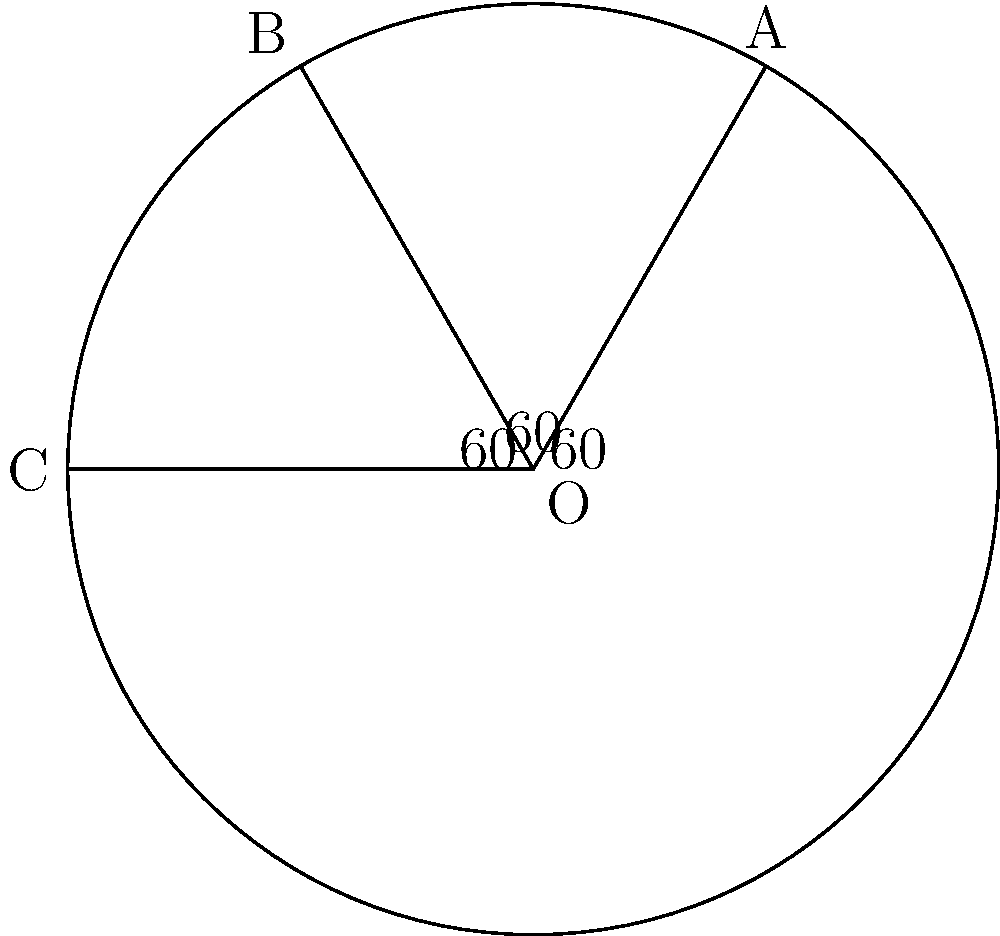In your 19th-century literature reading room, you've arranged three open books on a circular table, representing works by William Gilmore Simms. The books form three central angles of equal measure. If the angle between the first and third book is 120°, what is the measure of the angle formed by each open book? Let's approach this step-by-step:

1) First, let's recall that the sum of angles in a circle is 360°.

2) We're told that the books form three central angles of equal measure. Let's call the measure of each angle $x°$.

3) We're also told that the angle between the first and third book is 120°. This means that the sum of two of our equal angles is 120°.

4) We can express this as an equation:
   $2x = 120°$

5) Solving for $x$:
   $x = 120° ÷ 2 = 60°$

6) To verify, let's check if three 60° angles sum to 360°:
   $60° + 60° + 60° = 180°$

7) Indeed, this is correct, as 180° is half of 360°, which corresponds to the semicircle formed by the three books.

Therefore, each open book forms a central angle of 60°.
Answer: 60° 